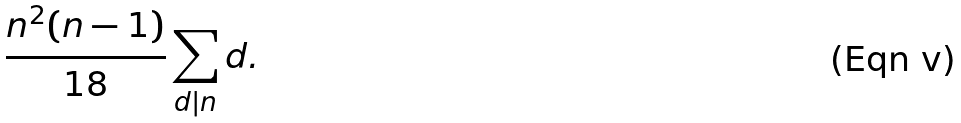<formula> <loc_0><loc_0><loc_500><loc_500>\frac { n ^ { 2 } ( n - 1 ) } { 1 8 } \sum _ { d | n } d .</formula> 